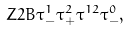<formula> <loc_0><loc_0><loc_500><loc_500>Z 2 B \tau ^ { 1 } _ { - } \tau ^ { 2 } _ { + } \tau ^ { 1 2 } \tau ^ { 0 } _ { - } ,</formula> 